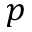Convert formula to latex. <formula><loc_0><loc_0><loc_500><loc_500>p</formula> 